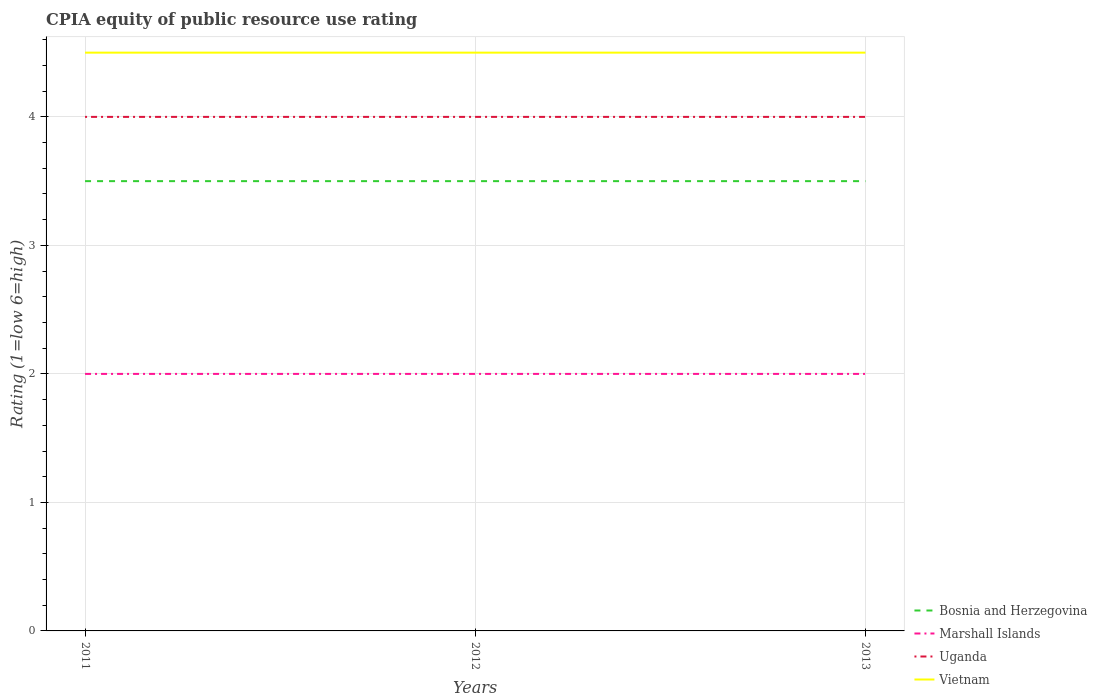How many different coloured lines are there?
Your answer should be compact. 4. Does the line corresponding to Vietnam intersect with the line corresponding to Marshall Islands?
Give a very brief answer. No. Is the number of lines equal to the number of legend labels?
Offer a very short reply. Yes. Across all years, what is the maximum CPIA rating in Uganda?
Provide a succinct answer. 4. In which year was the CPIA rating in Uganda maximum?
Keep it short and to the point. 2011. What is the difference between the highest and the second highest CPIA rating in Uganda?
Provide a short and direct response. 0. What is the difference between the highest and the lowest CPIA rating in Bosnia and Herzegovina?
Offer a terse response. 0. Does the graph contain grids?
Keep it short and to the point. Yes. Where does the legend appear in the graph?
Ensure brevity in your answer.  Bottom right. How many legend labels are there?
Your answer should be very brief. 4. What is the title of the graph?
Your answer should be very brief. CPIA equity of public resource use rating. What is the label or title of the Y-axis?
Offer a very short reply. Rating (1=low 6=high). What is the Rating (1=low 6=high) in Bosnia and Herzegovina in 2011?
Provide a succinct answer. 3.5. What is the Rating (1=low 6=high) of Marshall Islands in 2011?
Keep it short and to the point. 2. What is the Rating (1=low 6=high) of Uganda in 2011?
Provide a succinct answer. 4. What is the Rating (1=low 6=high) of Vietnam in 2011?
Provide a short and direct response. 4.5. What is the Rating (1=low 6=high) in Bosnia and Herzegovina in 2012?
Your response must be concise. 3.5. What is the Rating (1=low 6=high) in Uganda in 2012?
Your response must be concise. 4. What is the Rating (1=low 6=high) of Vietnam in 2012?
Offer a very short reply. 4.5. What is the Rating (1=low 6=high) in Bosnia and Herzegovina in 2013?
Your answer should be compact. 3.5. What is the Rating (1=low 6=high) in Marshall Islands in 2013?
Your answer should be very brief. 2. What is the Rating (1=low 6=high) in Uganda in 2013?
Give a very brief answer. 4. What is the Rating (1=low 6=high) in Vietnam in 2013?
Your answer should be compact. 4.5. Across all years, what is the maximum Rating (1=low 6=high) in Uganda?
Ensure brevity in your answer.  4. Across all years, what is the maximum Rating (1=low 6=high) of Vietnam?
Make the answer very short. 4.5. Across all years, what is the minimum Rating (1=low 6=high) of Bosnia and Herzegovina?
Offer a terse response. 3.5. Across all years, what is the minimum Rating (1=low 6=high) of Uganda?
Your answer should be compact. 4. What is the total Rating (1=low 6=high) in Vietnam in the graph?
Offer a very short reply. 13.5. What is the difference between the Rating (1=low 6=high) of Bosnia and Herzegovina in 2011 and that in 2012?
Offer a very short reply. 0. What is the difference between the Rating (1=low 6=high) of Uganda in 2011 and that in 2012?
Your answer should be very brief. 0. What is the difference between the Rating (1=low 6=high) in Bosnia and Herzegovina in 2011 and that in 2013?
Give a very brief answer. 0. What is the difference between the Rating (1=low 6=high) of Marshall Islands in 2011 and that in 2013?
Provide a short and direct response. 0. What is the difference between the Rating (1=low 6=high) of Uganda in 2011 and that in 2013?
Your answer should be compact. 0. What is the difference between the Rating (1=low 6=high) in Vietnam in 2011 and that in 2013?
Offer a very short reply. 0. What is the difference between the Rating (1=low 6=high) of Marshall Islands in 2012 and that in 2013?
Your answer should be very brief. 0. What is the difference between the Rating (1=low 6=high) in Vietnam in 2012 and that in 2013?
Give a very brief answer. 0. What is the difference between the Rating (1=low 6=high) in Bosnia and Herzegovina in 2011 and the Rating (1=low 6=high) in Marshall Islands in 2012?
Your answer should be very brief. 1.5. What is the difference between the Rating (1=low 6=high) of Bosnia and Herzegovina in 2011 and the Rating (1=low 6=high) of Vietnam in 2012?
Provide a short and direct response. -1. What is the difference between the Rating (1=low 6=high) of Marshall Islands in 2011 and the Rating (1=low 6=high) of Uganda in 2012?
Offer a terse response. -2. What is the difference between the Rating (1=low 6=high) of Marshall Islands in 2011 and the Rating (1=low 6=high) of Vietnam in 2012?
Ensure brevity in your answer.  -2.5. What is the difference between the Rating (1=low 6=high) in Uganda in 2011 and the Rating (1=low 6=high) in Vietnam in 2012?
Your answer should be very brief. -0.5. What is the difference between the Rating (1=low 6=high) in Bosnia and Herzegovina in 2011 and the Rating (1=low 6=high) in Uganda in 2013?
Make the answer very short. -0.5. What is the difference between the Rating (1=low 6=high) of Bosnia and Herzegovina in 2011 and the Rating (1=low 6=high) of Vietnam in 2013?
Give a very brief answer. -1. What is the difference between the Rating (1=low 6=high) of Marshall Islands in 2011 and the Rating (1=low 6=high) of Uganda in 2013?
Your response must be concise. -2. What is the difference between the Rating (1=low 6=high) in Marshall Islands in 2011 and the Rating (1=low 6=high) in Vietnam in 2013?
Give a very brief answer. -2.5. What is the difference between the Rating (1=low 6=high) in Uganda in 2011 and the Rating (1=low 6=high) in Vietnam in 2013?
Give a very brief answer. -0.5. What is the difference between the Rating (1=low 6=high) in Bosnia and Herzegovina in 2012 and the Rating (1=low 6=high) in Uganda in 2013?
Offer a terse response. -0.5. What is the difference between the Rating (1=low 6=high) of Bosnia and Herzegovina in 2012 and the Rating (1=low 6=high) of Vietnam in 2013?
Provide a short and direct response. -1. What is the difference between the Rating (1=low 6=high) in Uganda in 2012 and the Rating (1=low 6=high) in Vietnam in 2013?
Your answer should be very brief. -0.5. In the year 2011, what is the difference between the Rating (1=low 6=high) in Bosnia and Herzegovina and Rating (1=low 6=high) in Marshall Islands?
Make the answer very short. 1.5. In the year 2011, what is the difference between the Rating (1=low 6=high) in Bosnia and Herzegovina and Rating (1=low 6=high) in Uganda?
Give a very brief answer. -0.5. In the year 2011, what is the difference between the Rating (1=low 6=high) in Bosnia and Herzegovina and Rating (1=low 6=high) in Vietnam?
Your response must be concise. -1. In the year 2011, what is the difference between the Rating (1=low 6=high) of Marshall Islands and Rating (1=low 6=high) of Vietnam?
Ensure brevity in your answer.  -2.5. In the year 2012, what is the difference between the Rating (1=low 6=high) in Bosnia and Herzegovina and Rating (1=low 6=high) in Marshall Islands?
Offer a terse response. 1.5. In the year 2012, what is the difference between the Rating (1=low 6=high) in Bosnia and Herzegovina and Rating (1=low 6=high) in Uganda?
Provide a short and direct response. -0.5. In the year 2012, what is the difference between the Rating (1=low 6=high) of Bosnia and Herzegovina and Rating (1=low 6=high) of Vietnam?
Provide a short and direct response. -1. In the year 2012, what is the difference between the Rating (1=low 6=high) of Uganda and Rating (1=low 6=high) of Vietnam?
Keep it short and to the point. -0.5. In the year 2013, what is the difference between the Rating (1=low 6=high) in Bosnia and Herzegovina and Rating (1=low 6=high) in Vietnam?
Your response must be concise. -1. In the year 2013, what is the difference between the Rating (1=low 6=high) of Uganda and Rating (1=low 6=high) of Vietnam?
Your answer should be compact. -0.5. What is the ratio of the Rating (1=low 6=high) of Uganda in 2011 to that in 2013?
Offer a terse response. 1. What is the ratio of the Rating (1=low 6=high) in Marshall Islands in 2012 to that in 2013?
Provide a short and direct response. 1. What is the difference between the highest and the second highest Rating (1=low 6=high) in Bosnia and Herzegovina?
Offer a very short reply. 0. What is the difference between the highest and the second highest Rating (1=low 6=high) of Marshall Islands?
Offer a terse response. 0. What is the difference between the highest and the second highest Rating (1=low 6=high) in Vietnam?
Provide a succinct answer. 0. What is the difference between the highest and the lowest Rating (1=low 6=high) in Bosnia and Herzegovina?
Your response must be concise. 0. What is the difference between the highest and the lowest Rating (1=low 6=high) of Marshall Islands?
Ensure brevity in your answer.  0. What is the difference between the highest and the lowest Rating (1=low 6=high) of Uganda?
Your response must be concise. 0. What is the difference between the highest and the lowest Rating (1=low 6=high) in Vietnam?
Make the answer very short. 0. 